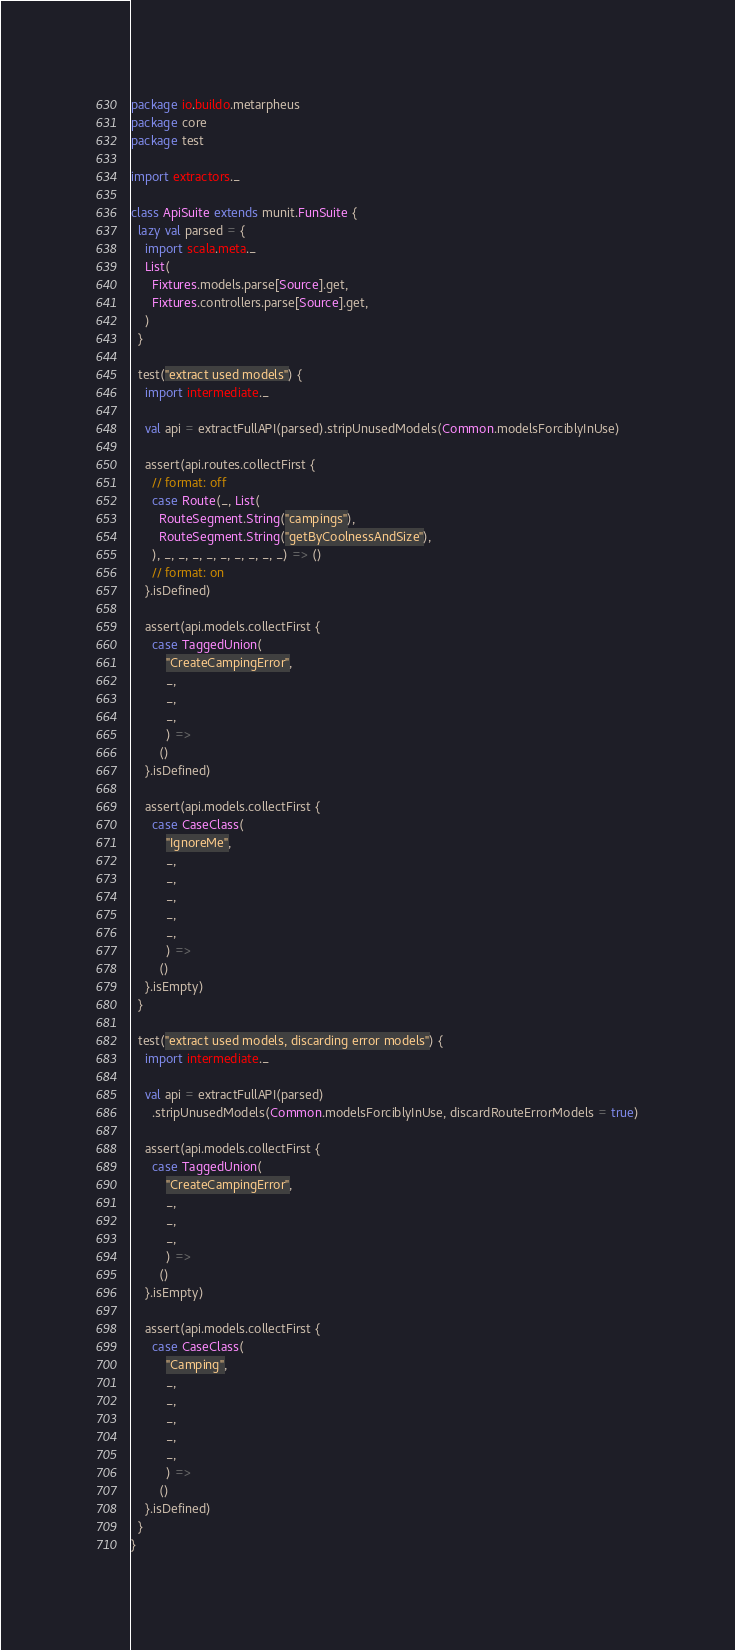<code> <loc_0><loc_0><loc_500><loc_500><_Scala_>package io.buildo.metarpheus
package core
package test

import extractors._

class ApiSuite extends munit.FunSuite {
  lazy val parsed = {
    import scala.meta._
    List(
      Fixtures.models.parse[Source].get,
      Fixtures.controllers.parse[Source].get,
    )
  }

  test("extract used models") {
    import intermediate._

    val api = extractFullAPI(parsed).stripUnusedModels(Common.modelsForciblyInUse)

    assert(api.routes.collectFirst {
      // format: off
      case Route(_, List(
        RouteSegment.String("campings"),
        RouteSegment.String("getByCoolnessAndSize"),
      ), _, _, _, _, _, _, _, _, _) => ()
      // format: on
    }.isDefined)

    assert(api.models.collectFirst {
      case TaggedUnion(
          "CreateCampingError",
          _,
          _,
          _,
          ) =>
        ()
    }.isDefined)

    assert(api.models.collectFirst {
      case CaseClass(
          "IgnoreMe",
          _,
          _,
          _,
          _,
          _,
          ) =>
        ()
    }.isEmpty)
  }

  test("extract used models, discarding error models") {
    import intermediate._

    val api = extractFullAPI(parsed)
      .stripUnusedModels(Common.modelsForciblyInUse, discardRouteErrorModels = true)

    assert(api.models.collectFirst {
      case TaggedUnion(
          "CreateCampingError",
          _,
          _,
          _,
          ) =>
        ()
    }.isEmpty)

    assert(api.models.collectFirst {
      case CaseClass(
          "Camping",
          _,
          _,
          _,
          _,
          _,
          ) =>
        ()
    }.isDefined)
  }
}
</code> 